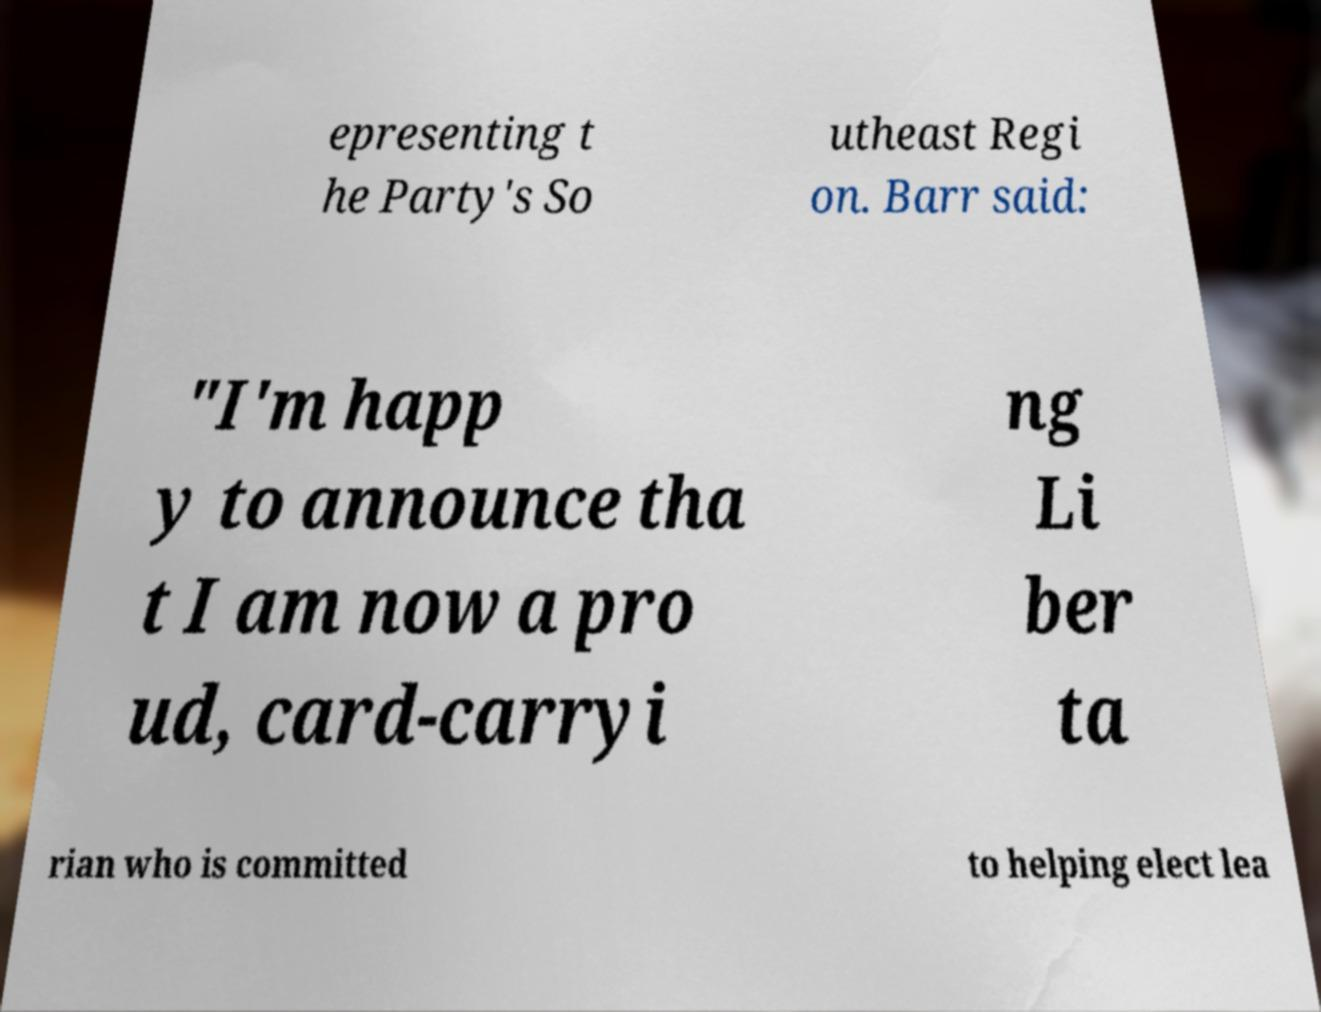Please read and relay the text visible in this image. What does it say? epresenting t he Party's So utheast Regi on. Barr said: "I'm happ y to announce tha t I am now a pro ud, card-carryi ng Li ber ta rian who is committed to helping elect lea 